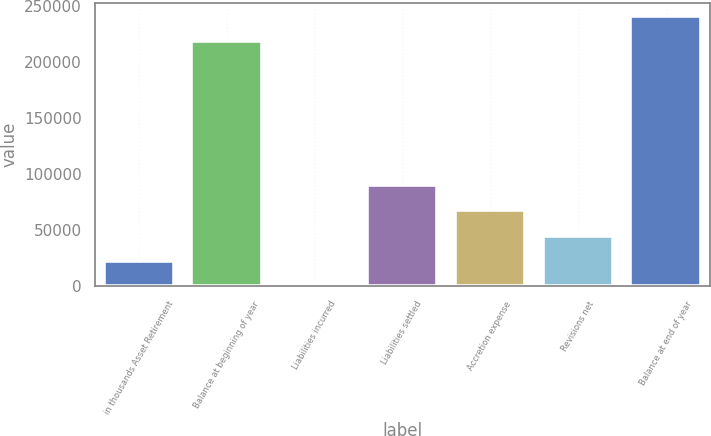<chart> <loc_0><loc_0><loc_500><loc_500><bar_chart><fcel>in thousands Asset Retirement<fcel>Balance at beginning of year<fcel>Liabilities incurred<fcel>Liabilities settled<fcel>Accretion expense<fcel>Revisions net<fcel>Balance at end of year<nl><fcel>22590.6<fcel>218117<fcel>20<fcel>90302.4<fcel>67731.8<fcel>45161.2<fcel>240688<nl></chart> 